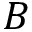<formula> <loc_0><loc_0><loc_500><loc_500>B</formula> 